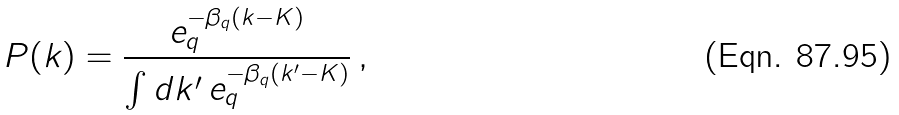Convert formula to latex. <formula><loc_0><loc_0><loc_500><loc_500>P ( k ) = \frac { e _ { q } ^ { - \beta _ { q } ( k - K ) } } { \int d k ^ { \prime } \, e _ { q } ^ { - \beta _ { q } ( k ^ { \prime } - K ) } } \, ,</formula> 